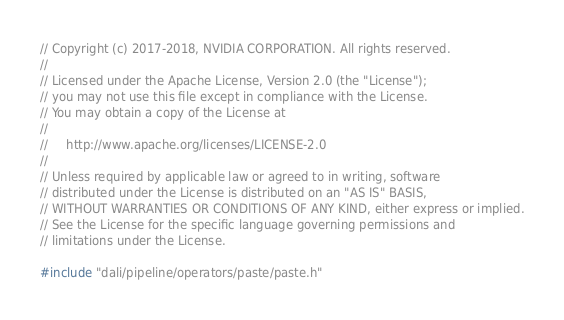<code> <loc_0><loc_0><loc_500><loc_500><_Cuda_>// Copyright (c) 2017-2018, NVIDIA CORPORATION. All rights reserved.
//
// Licensed under the Apache License, Version 2.0 (the "License");
// you may not use this file except in compliance with the License.
// You may obtain a copy of the License at
//
//     http://www.apache.org/licenses/LICENSE-2.0
//
// Unless required by applicable law or agreed to in writing, software
// distributed under the License is distributed on an "AS IS" BASIS,
// WITHOUT WARRANTIES OR CONDITIONS OF ANY KIND, either express or implied.
// See the License for the specific language governing permissions and
// limitations under the License.

#include "dali/pipeline/operators/paste/paste.h"
</code> 